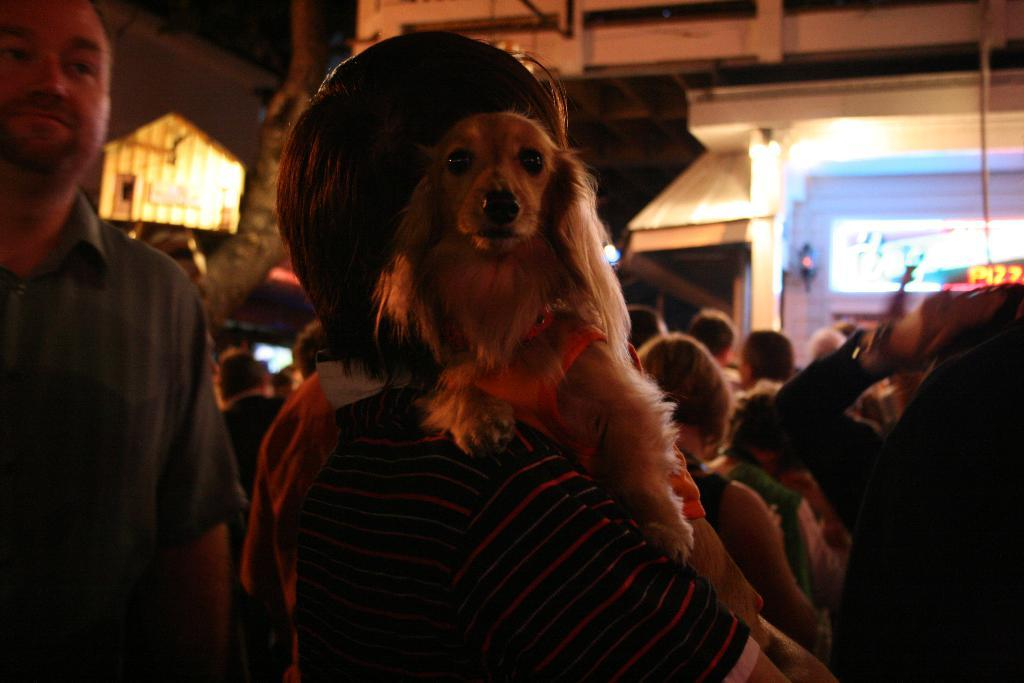What is the main subject of the image? There is a group of people in the image. Can you describe the interaction between the people and an animal in the image? A dog is sitting on a person in the image. What can be seen in the background of the image? There are buildings in the background of the image. What type of paper is being used by the class in the image? There is no class or paper present in the image; it features a group of people and a dog. What shape is the square that the dog is sitting on in the image? There is no square present in the image; the dog is sitting on a person. 